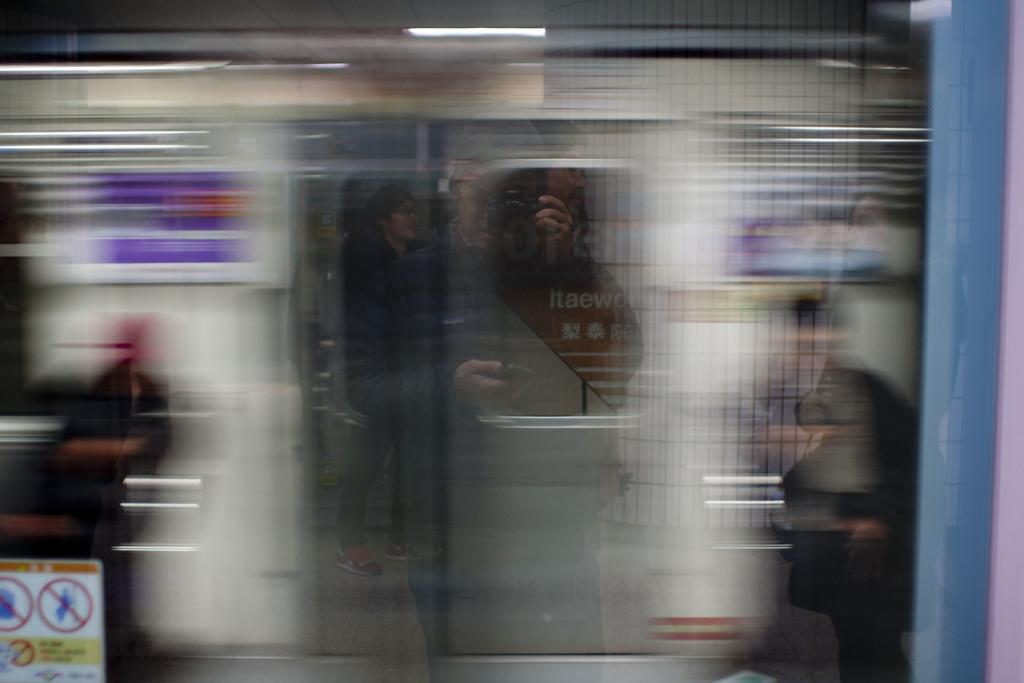What is the person in the image doing? The person is clicking a picture. What is the subject of the picture being taken? The subject of the picture is a moving train. How would you describe the quality of the image? The image is blurred. Is there any mention of payment in the image? No, there is no mention of payment in the image. How many ducks are visible in the image? There are no ducks present in the image. 